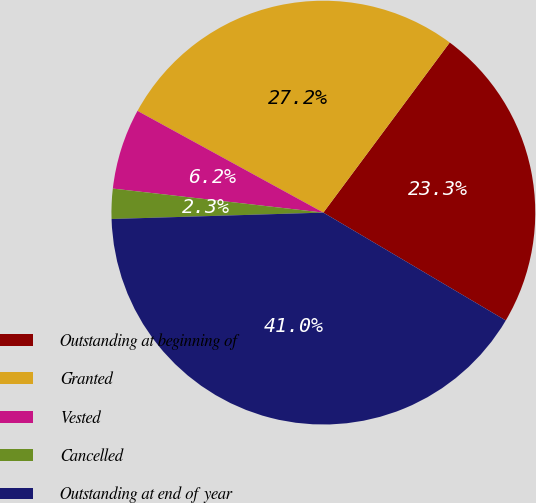<chart> <loc_0><loc_0><loc_500><loc_500><pie_chart><fcel>Outstanding at beginning of<fcel>Granted<fcel>Vested<fcel>Cancelled<fcel>Outstanding at end of year<nl><fcel>23.33%<fcel>27.2%<fcel>6.16%<fcel>2.29%<fcel>41.02%<nl></chart> 